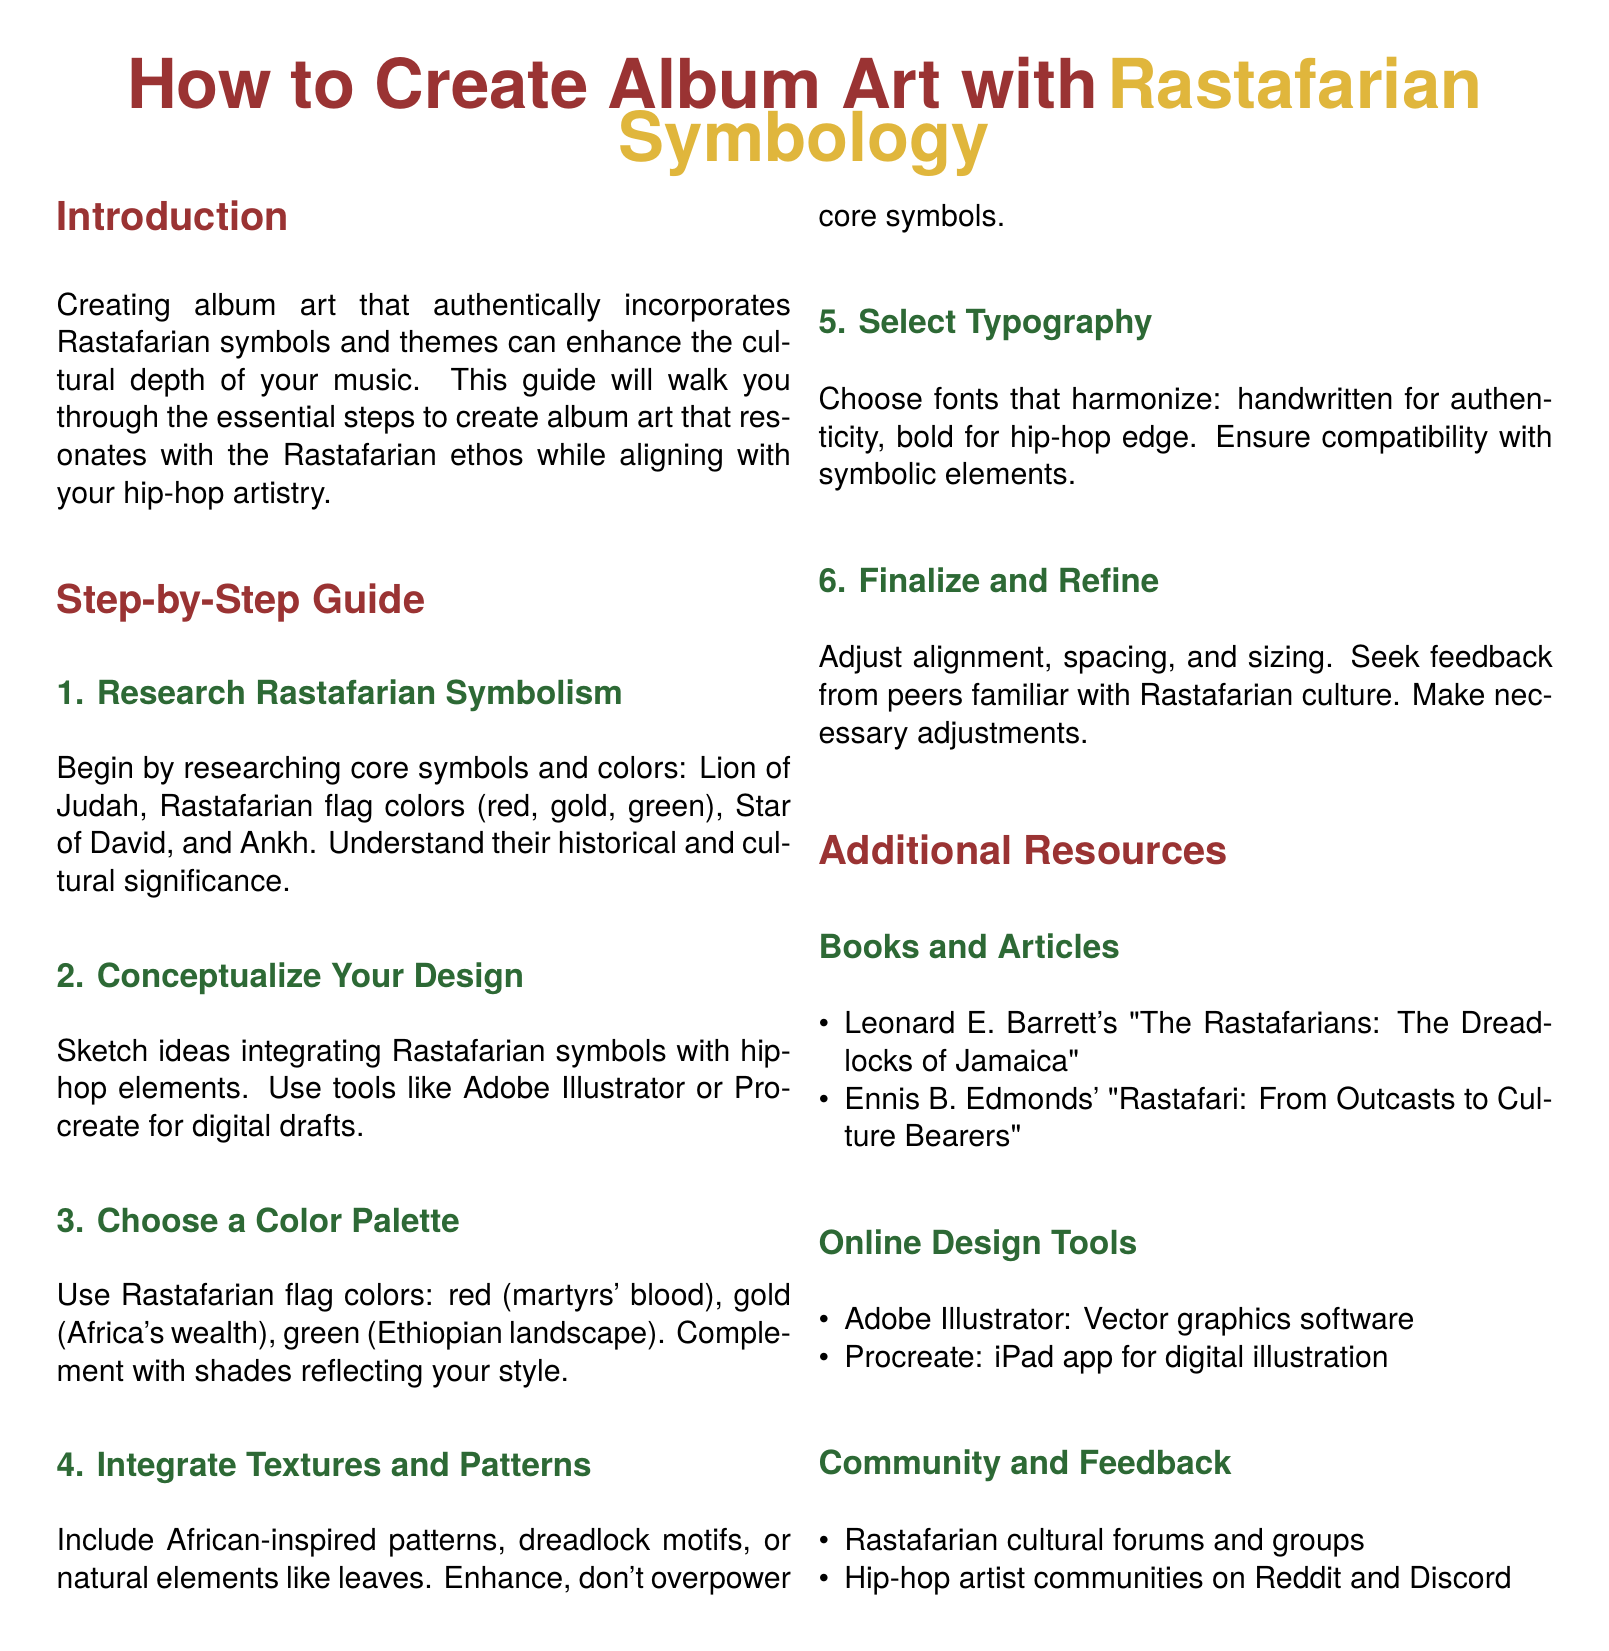What is the primary theme of the guide? The guide focuses on creating album art with Rastafarian symbology.
Answer: Rastafarian symbology How many steps are outlined in the guide? The guide provides a step-by-step process consisting of six distinct steps.
Answer: 6 What colors are associated with Rastafarian symbolism? The guide details the colors of the Rastafarian flag, which are red, gold, and green.
Answer: Red, gold, green Which software is recommended for digital drafts? The guide suggests tools like Adobe Illustrator and Procreate for creating digital designs.
Answer: Adobe Illustrator, Procreate What type of typography is suggested for authenticity? The document recommends using handwritten fonts for a more authentic look.
Answer: Handwritten What is the significance of the color green in Rastafarian culture? The guide states that green represents the Ethiopian landscape in Rastafarian symbolism.
Answer: Ethiopian landscape What is one additional resource mentioned for learning more about Rastafarian culture? The guide lists Leonard E. Barrett's book as a resource for deeper understanding.
Answer: Leonard E. Barrett's book Which community platforms are mentioned for artist feedback? The guide suggests Rastafarian cultural forums and hip-hop artist communities on Reddit and Discord.
Answer: Reddit, Discord 